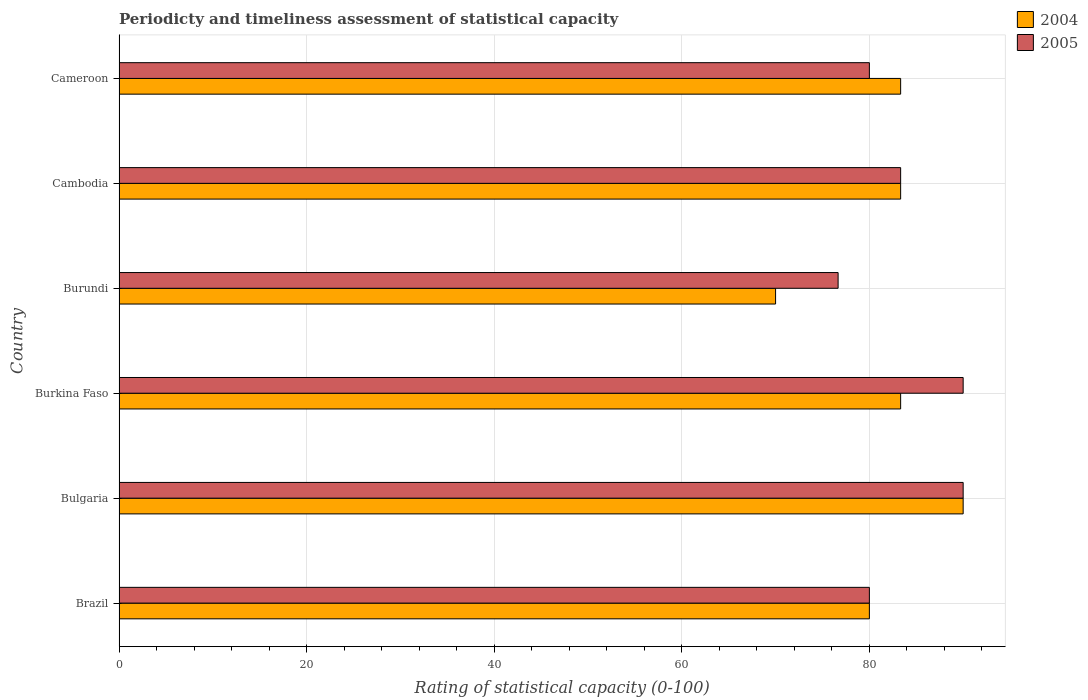How many different coloured bars are there?
Provide a succinct answer. 2. Are the number of bars on each tick of the Y-axis equal?
Ensure brevity in your answer.  Yes. How many bars are there on the 5th tick from the bottom?
Provide a succinct answer. 2. What is the label of the 3rd group of bars from the top?
Your answer should be compact. Burundi. In how many cases, is the number of bars for a given country not equal to the number of legend labels?
Provide a short and direct response. 0. What is the rating of statistical capacity in 2004 in Brazil?
Your answer should be very brief. 80. Across all countries, what is the maximum rating of statistical capacity in 2004?
Give a very brief answer. 90. Across all countries, what is the minimum rating of statistical capacity in 2005?
Ensure brevity in your answer.  76.67. In which country was the rating of statistical capacity in 2005 maximum?
Your answer should be very brief. Bulgaria. In which country was the rating of statistical capacity in 2005 minimum?
Provide a short and direct response. Burundi. What is the total rating of statistical capacity in 2004 in the graph?
Provide a short and direct response. 490. What is the difference between the rating of statistical capacity in 2005 in Brazil and that in Cameroon?
Offer a very short reply. 0. What is the average rating of statistical capacity in 2005 per country?
Provide a short and direct response. 83.33. What is the difference between the rating of statistical capacity in 2005 and rating of statistical capacity in 2004 in Burkina Faso?
Ensure brevity in your answer.  6.67. In how many countries, is the rating of statistical capacity in 2005 greater than 56 ?
Your response must be concise. 6. What is the ratio of the rating of statistical capacity in 2005 in Bulgaria to that in Burkina Faso?
Ensure brevity in your answer.  1. What is the difference between the highest and the second highest rating of statistical capacity in 2005?
Offer a very short reply. 0. What is the difference between the highest and the lowest rating of statistical capacity in 2004?
Your answer should be very brief. 20. In how many countries, is the rating of statistical capacity in 2004 greater than the average rating of statistical capacity in 2004 taken over all countries?
Your answer should be compact. 4. How many bars are there?
Keep it short and to the point. 12. How many countries are there in the graph?
Provide a succinct answer. 6. Does the graph contain any zero values?
Ensure brevity in your answer.  No. Does the graph contain grids?
Your answer should be very brief. Yes. Where does the legend appear in the graph?
Provide a short and direct response. Top right. How many legend labels are there?
Offer a terse response. 2. What is the title of the graph?
Your answer should be very brief. Periodicty and timeliness assessment of statistical capacity. Does "2011" appear as one of the legend labels in the graph?
Offer a terse response. No. What is the label or title of the X-axis?
Your answer should be compact. Rating of statistical capacity (0-100). What is the label or title of the Y-axis?
Offer a very short reply. Country. What is the Rating of statistical capacity (0-100) in 2004 in Brazil?
Your response must be concise. 80. What is the Rating of statistical capacity (0-100) in 2005 in Bulgaria?
Your response must be concise. 90. What is the Rating of statistical capacity (0-100) in 2004 in Burkina Faso?
Make the answer very short. 83.33. What is the Rating of statistical capacity (0-100) of 2005 in Burkina Faso?
Offer a very short reply. 90. What is the Rating of statistical capacity (0-100) of 2005 in Burundi?
Offer a terse response. 76.67. What is the Rating of statistical capacity (0-100) in 2004 in Cambodia?
Keep it short and to the point. 83.33. What is the Rating of statistical capacity (0-100) of 2005 in Cambodia?
Keep it short and to the point. 83.33. What is the Rating of statistical capacity (0-100) of 2004 in Cameroon?
Provide a short and direct response. 83.33. What is the Rating of statistical capacity (0-100) in 2005 in Cameroon?
Your answer should be very brief. 80. Across all countries, what is the maximum Rating of statistical capacity (0-100) in 2004?
Provide a succinct answer. 90. Across all countries, what is the maximum Rating of statistical capacity (0-100) in 2005?
Ensure brevity in your answer.  90. Across all countries, what is the minimum Rating of statistical capacity (0-100) in 2004?
Provide a short and direct response. 70. Across all countries, what is the minimum Rating of statistical capacity (0-100) of 2005?
Ensure brevity in your answer.  76.67. What is the total Rating of statistical capacity (0-100) in 2004 in the graph?
Ensure brevity in your answer.  490. What is the total Rating of statistical capacity (0-100) of 2005 in the graph?
Give a very brief answer. 500. What is the difference between the Rating of statistical capacity (0-100) of 2004 in Brazil and that in Bulgaria?
Your answer should be compact. -10. What is the difference between the Rating of statistical capacity (0-100) in 2004 in Brazil and that in Burkina Faso?
Offer a very short reply. -3.33. What is the difference between the Rating of statistical capacity (0-100) in 2005 in Brazil and that in Burkina Faso?
Offer a very short reply. -10. What is the difference between the Rating of statistical capacity (0-100) in 2005 in Brazil and that in Burundi?
Offer a terse response. 3.33. What is the difference between the Rating of statistical capacity (0-100) in 2004 in Brazil and that in Cambodia?
Your response must be concise. -3.33. What is the difference between the Rating of statistical capacity (0-100) of 2005 in Brazil and that in Cambodia?
Offer a very short reply. -3.33. What is the difference between the Rating of statistical capacity (0-100) of 2004 in Brazil and that in Cameroon?
Your answer should be very brief. -3.33. What is the difference between the Rating of statistical capacity (0-100) in 2005 in Brazil and that in Cameroon?
Your answer should be compact. 0. What is the difference between the Rating of statistical capacity (0-100) of 2004 in Bulgaria and that in Burkina Faso?
Provide a succinct answer. 6.67. What is the difference between the Rating of statistical capacity (0-100) in 2005 in Bulgaria and that in Burkina Faso?
Offer a very short reply. 0. What is the difference between the Rating of statistical capacity (0-100) of 2005 in Bulgaria and that in Burundi?
Provide a succinct answer. 13.33. What is the difference between the Rating of statistical capacity (0-100) of 2004 in Bulgaria and that in Cameroon?
Your answer should be very brief. 6.67. What is the difference between the Rating of statistical capacity (0-100) of 2004 in Burkina Faso and that in Burundi?
Give a very brief answer. 13.33. What is the difference between the Rating of statistical capacity (0-100) in 2005 in Burkina Faso and that in Burundi?
Offer a terse response. 13.33. What is the difference between the Rating of statistical capacity (0-100) in 2004 in Burkina Faso and that in Cambodia?
Keep it short and to the point. 0. What is the difference between the Rating of statistical capacity (0-100) of 2004 in Burkina Faso and that in Cameroon?
Your answer should be compact. 0. What is the difference between the Rating of statistical capacity (0-100) of 2004 in Burundi and that in Cambodia?
Provide a short and direct response. -13.33. What is the difference between the Rating of statistical capacity (0-100) in 2005 in Burundi and that in Cambodia?
Provide a succinct answer. -6.67. What is the difference between the Rating of statistical capacity (0-100) in 2004 in Burundi and that in Cameroon?
Provide a succinct answer. -13.33. What is the difference between the Rating of statistical capacity (0-100) in 2005 in Cambodia and that in Cameroon?
Offer a very short reply. 3.33. What is the difference between the Rating of statistical capacity (0-100) in 2004 in Brazil and the Rating of statistical capacity (0-100) in 2005 in Cameroon?
Offer a terse response. 0. What is the difference between the Rating of statistical capacity (0-100) of 2004 in Bulgaria and the Rating of statistical capacity (0-100) of 2005 in Burundi?
Your response must be concise. 13.33. What is the difference between the Rating of statistical capacity (0-100) of 2004 in Bulgaria and the Rating of statistical capacity (0-100) of 2005 in Cambodia?
Provide a short and direct response. 6.67. What is the difference between the Rating of statistical capacity (0-100) of 2004 in Bulgaria and the Rating of statistical capacity (0-100) of 2005 in Cameroon?
Provide a short and direct response. 10. What is the difference between the Rating of statistical capacity (0-100) of 2004 in Burkina Faso and the Rating of statistical capacity (0-100) of 2005 in Cameroon?
Keep it short and to the point. 3.33. What is the difference between the Rating of statistical capacity (0-100) of 2004 in Burundi and the Rating of statistical capacity (0-100) of 2005 in Cambodia?
Your answer should be very brief. -13.33. What is the average Rating of statistical capacity (0-100) of 2004 per country?
Your answer should be compact. 81.67. What is the average Rating of statistical capacity (0-100) of 2005 per country?
Your answer should be compact. 83.33. What is the difference between the Rating of statistical capacity (0-100) of 2004 and Rating of statistical capacity (0-100) of 2005 in Brazil?
Your response must be concise. 0. What is the difference between the Rating of statistical capacity (0-100) in 2004 and Rating of statistical capacity (0-100) in 2005 in Bulgaria?
Ensure brevity in your answer.  0. What is the difference between the Rating of statistical capacity (0-100) in 2004 and Rating of statistical capacity (0-100) in 2005 in Burkina Faso?
Provide a succinct answer. -6.67. What is the difference between the Rating of statistical capacity (0-100) of 2004 and Rating of statistical capacity (0-100) of 2005 in Burundi?
Provide a short and direct response. -6.67. What is the difference between the Rating of statistical capacity (0-100) in 2004 and Rating of statistical capacity (0-100) in 2005 in Cambodia?
Provide a short and direct response. 0. What is the difference between the Rating of statistical capacity (0-100) of 2004 and Rating of statistical capacity (0-100) of 2005 in Cameroon?
Make the answer very short. 3.33. What is the ratio of the Rating of statistical capacity (0-100) in 2005 in Brazil to that in Bulgaria?
Give a very brief answer. 0.89. What is the ratio of the Rating of statistical capacity (0-100) in 2004 in Brazil to that in Burkina Faso?
Offer a terse response. 0.96. What is the ratio of the Rating of statistical capacity (0-100) in 2005 in Brazil to that in Burundi?
Ensure brevity in your answer.  1.04. What is the ratio of the Rating of statistical capacity (0-100) of 2005 in Brazil to that in Cambodia?
Ensure brevity in your answer.  0.96. What is the ratio of the Rating of statistical capacity (0-100) in 2004 in Brazil to that in Cameroon?
Make the answer very short. 0.96. What is the ratio of the Rating of statistical capacity (0-100) of 2005 in Brazil to that in Cameroon?
Give a very brief answer. 1. What is the ratio of the Rating of statistical capacity (0-100) of 2005 in Bulgaria to that in Burkina Faso?
Give a very brief answer. 1. What is the ratio of the Rating of statistical capacity (0-100) in 2005 in Bulgaria to that in Burundi?
Provide a short and direct response. 1.17. What is the ratio of the Rating of statistical capacity (0-100) of 2004 in Bulgaria to that in Cambodia?
Your answer should be compact. 1.08. What is the ratio of the Rating of statistical capacity (0-100) in 2005 in Bulgaria to that in Cambodia?
Keep it short and to the point. 1.08. What is the ratio of the Rating of statistical capacity (0-100) in 2004 in Burkina Faso to that in Burundi?
Your response must be concise. 1.19. What is the ratio of the Rating of statistical capacity (0-100) of 2005 in Burkina Faso to that in Burundi?
Offer a very short reply. 1.17. What is the ratio of the Rating of statistical capacity (0-100) of 2004 in Burkina Faso to that in Cambodia?
Your answer should be compact. 1. What is the ratio of the Rating of statistical capacity (0-100) in 2005 in Burkina Faso to that in Cambodia?
Your answer should be very brief. 1.08. What is the ratio of the Rating of statistical capacity (0-100) in 2004 in Burundi to that in Cambodia?
Offer a very short reply. 0.84. What is the ratio of the Rating of statistical capacity (0-100) in 2004 in Burundi to that in Cameroon?
Your response must be concise. 0.84. What is the ratio of the Rating of statistical capacity (0-100) of 2005 in Cambodia to that in Cameroon?
Offer a very short reply. 1.04. What is the difference between the highest and the second highest Rating of statistical capacity (0-100) of 2004?
Keep it short and to the point. 6.67. What is the difference between the highest and the lowest Rating of statistical capacity (0-100) of 2004?
Your answer should be compact. 20. What is the difference between the highest and the lowest Rating of statistical capacity (0-100) of 2005?
Give a very brief answer. 13.33. 